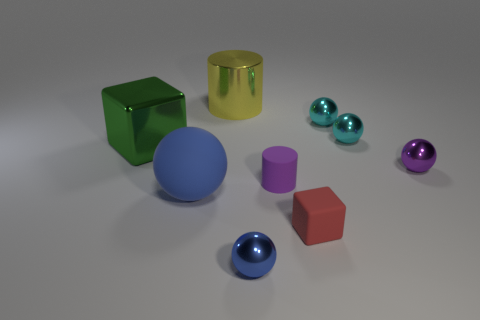There is a small metallic object that is the same color as the large ball; what is its shape?
Your answer should be very brief. Sphere. What number of things are either metal spheres that are in front of the large blue sphere or red things?
Your answer should be very brief. 2. What size is the blue ball that is the same material as the red block?
Offer a terse response. Large. There is a red block; is its size the same as the blue sphere behind the red cube?
Provide a short and direct response. No. There is a big thing that is behind the large matte ball and to the left of the big cylinder; what color is it?
Make the answer very short. Green. What number of things are tiny metal things that are left of the red object or tiny spheres in front of the big green block?
Provide a succinct answer. 2. What color is the cube left of the sphere in front of the block that is on the right side of the yellow metallic cylinder?
Give a very brief answer. Green. Are there any green things that have the same shape as the red thing?
Offer a very short reply. Yes. What number of tiny cyan metallic balls are there?
Your answer should be very brief. 2. What is the shape of the green metal object?
Your response must be concise. Cube. 